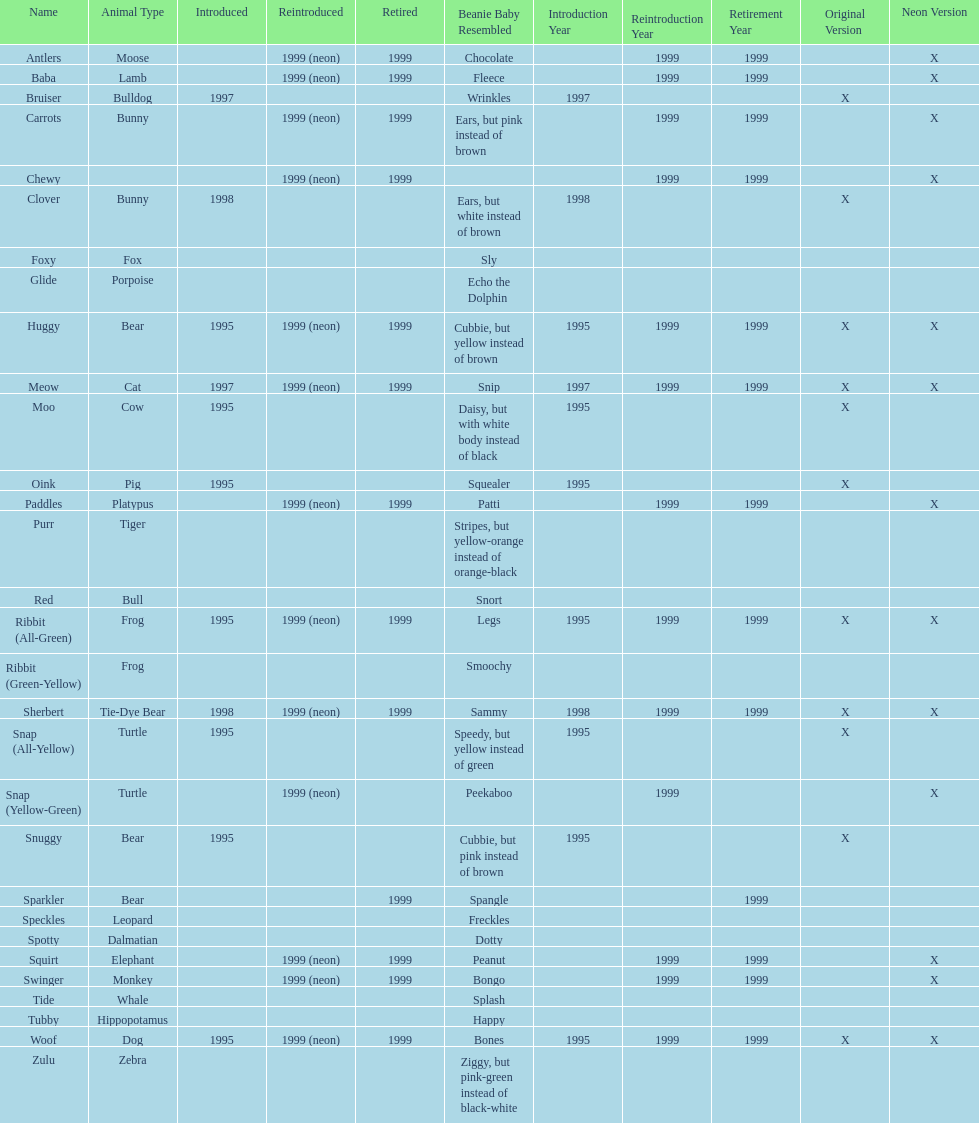How long was woof the dog sold before it was retired? 4 years. 